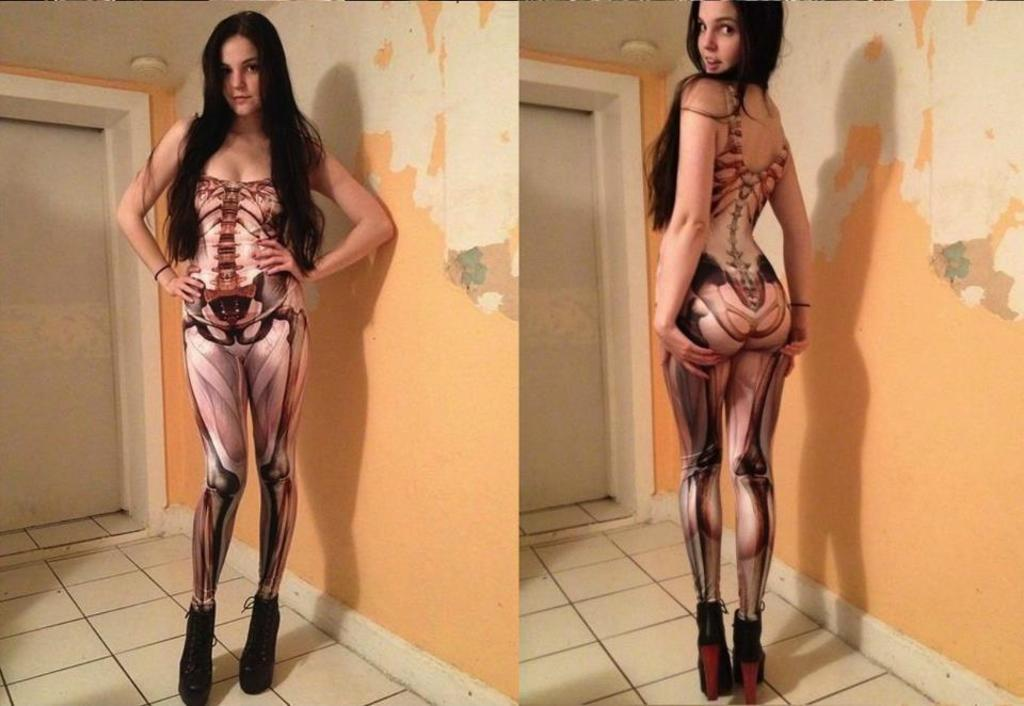What type of image is being described? The image is a collage. Can you describe the main subject in the image? There is a woman in the image. What is the woman doing in the image? The woman is standing and smiling. What is visible behind the woman in the image? There is a wall behind the woman. Can you tell me how many books are on the shelf in the library depicted in the image? There is no library or shelf with books present in the image; it features a collage with a woman standing and smiling in front of a wall. 